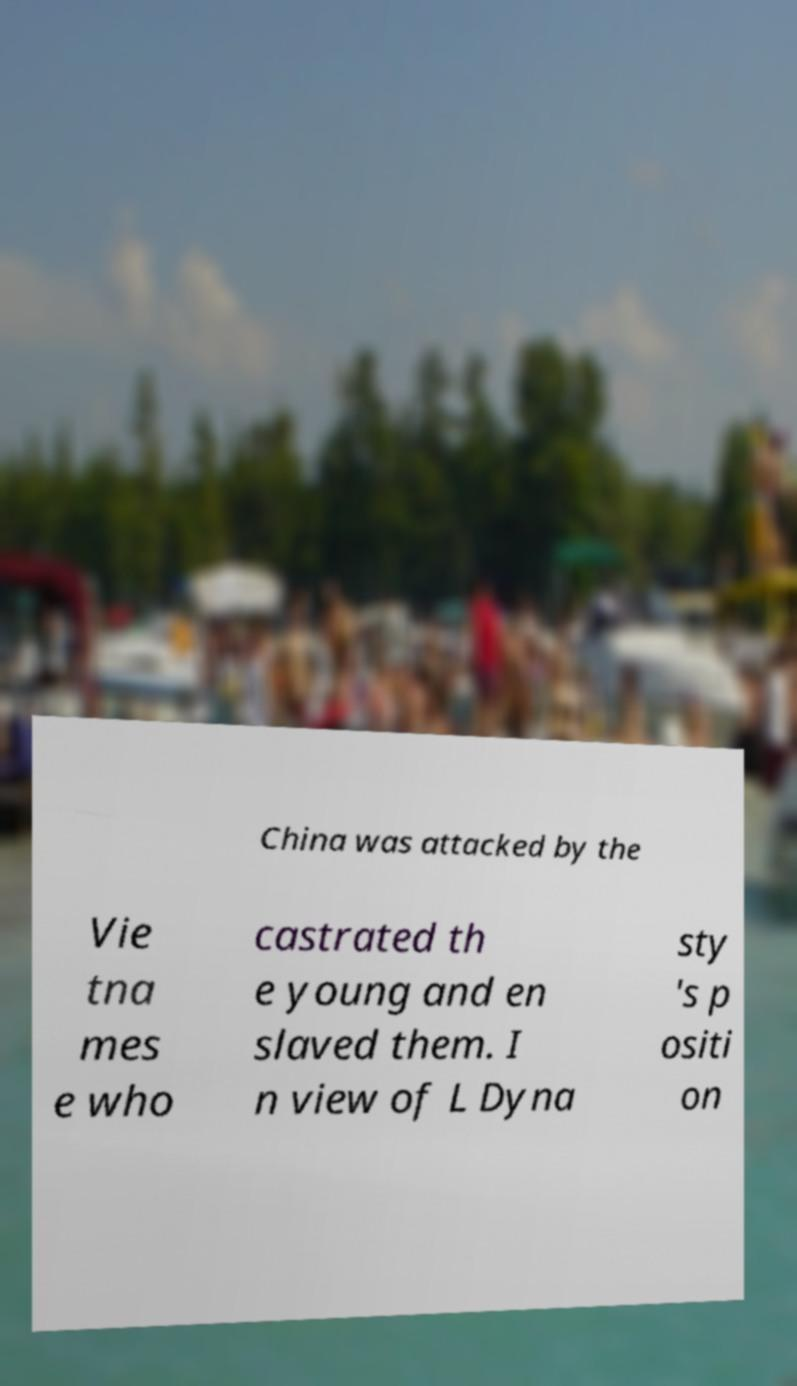For documentation purposes, I need the text within this image transcribed. Could you provide that? China was attacked by the Vie tna mes e who castrated th e young and en slaved them. I n view of L Dyna sty 's p ositi on 